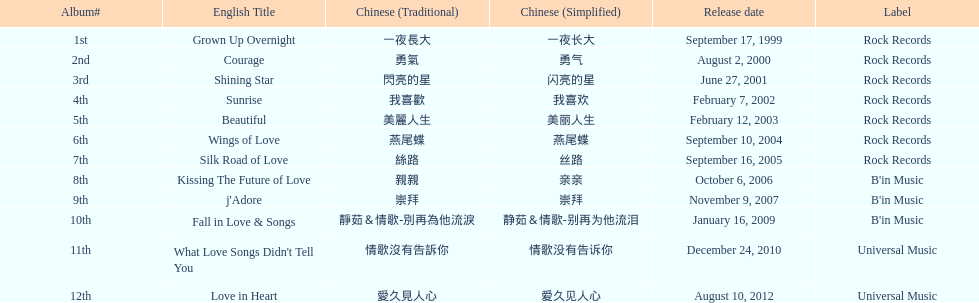What is the name of her last album produced with rock records? Silk Road of Love. 